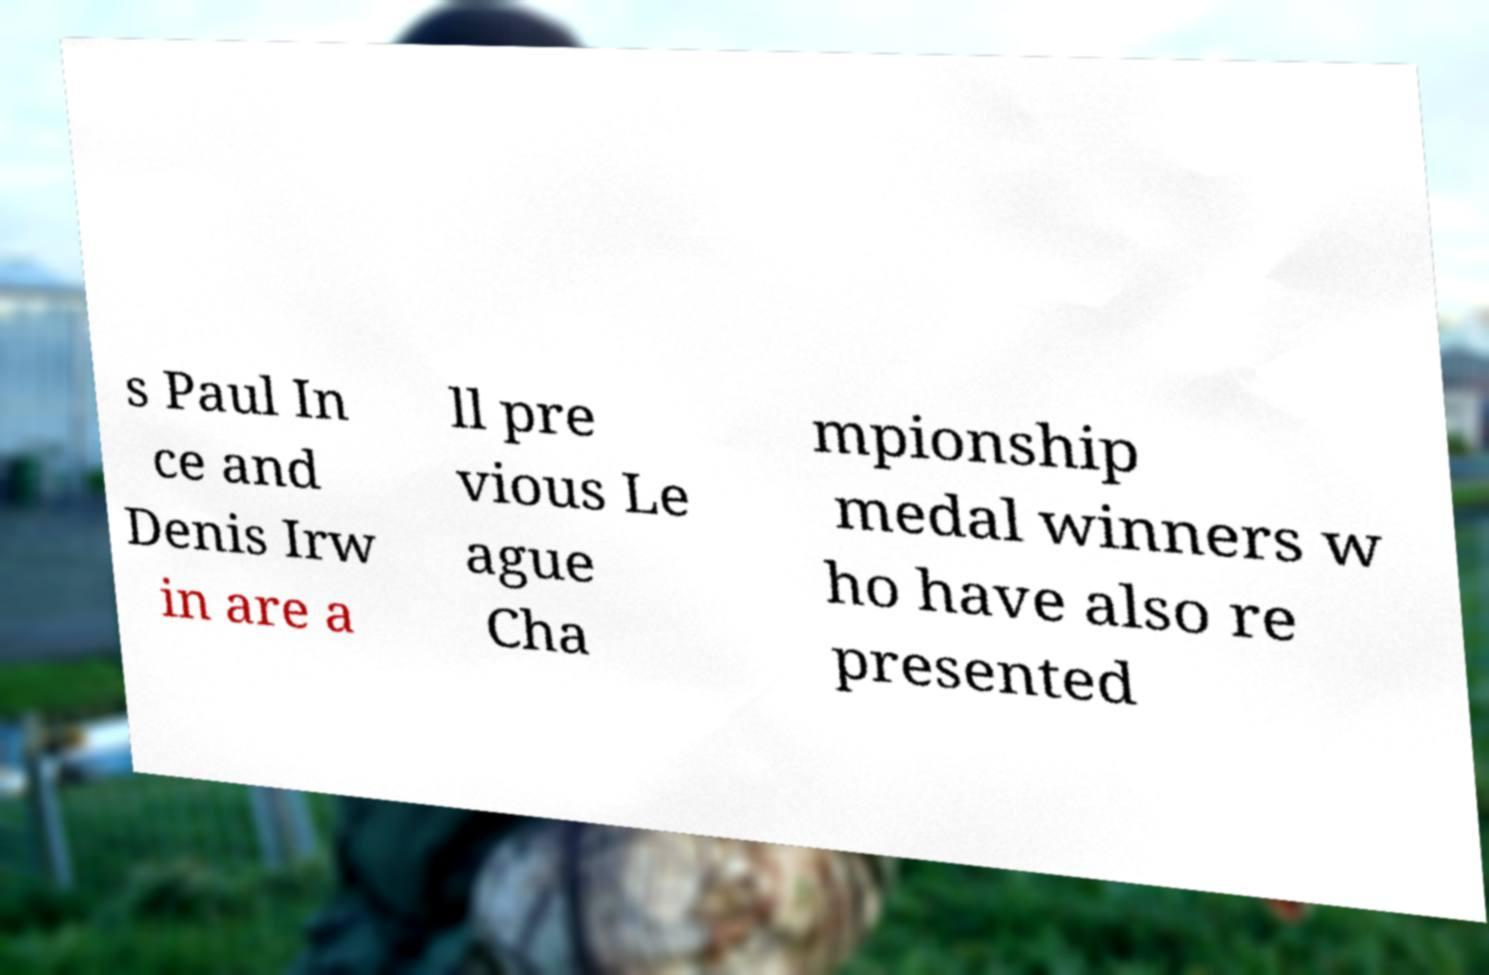Could you extract and type out the text from this image? s Paul In ce and Denis Irw in are a ll pre vious Le ague Cha mpionship medal winners w ho have also re presented 